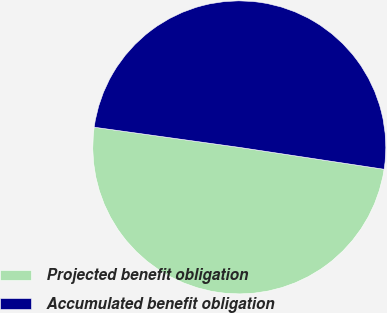Convert chart. <chart><loc_0><loc_0><loc_500><loc_500><pie_chart><fcel>Projected benefit obligation<fcel>Accumulated benefit obligation<nl><fcel>49.81%<fcel>50.19%<nl></chart> 